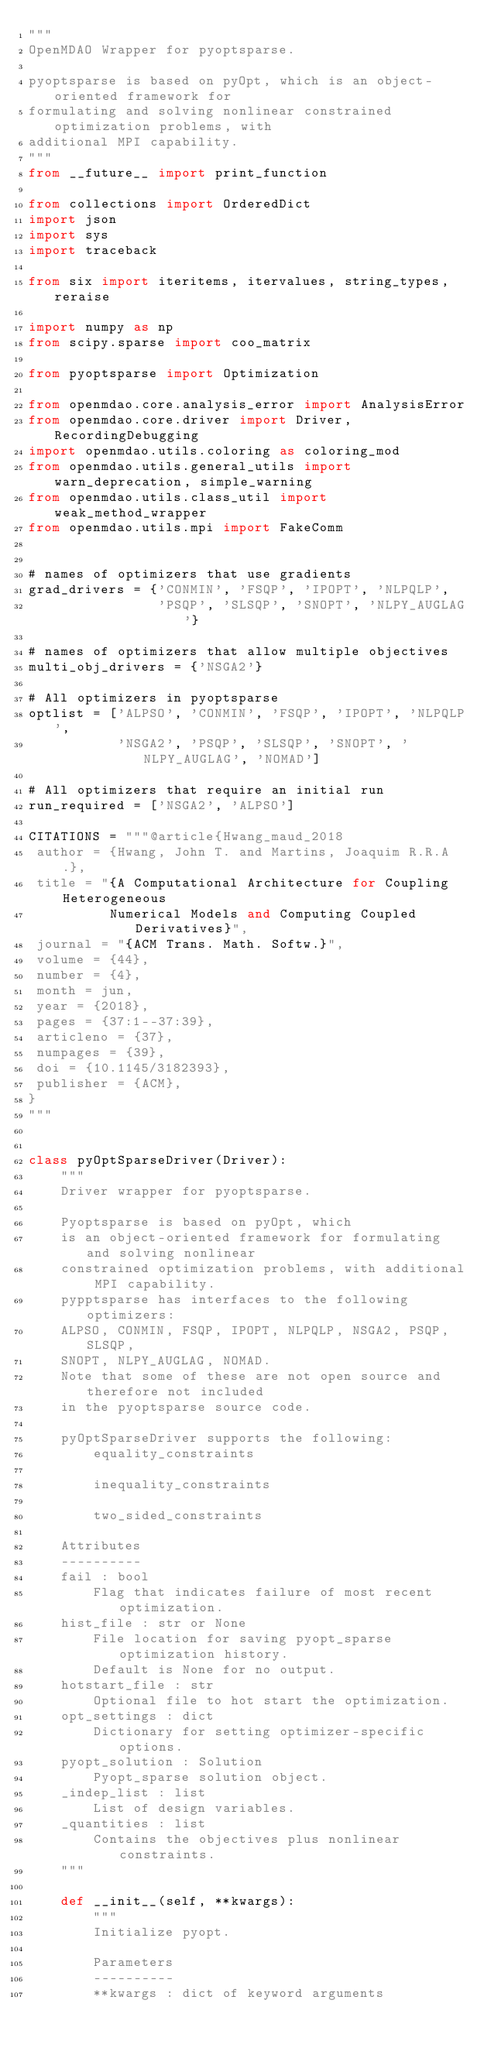Convert code to text. <code><loc_0><loc_0><loc_500><loc_500><_Python_>"""
OpenMDAO Wrapper for pyoptsparse.

pyoptsparse is based on pyOpt, which is an object-oriented framework for
formulating and solving nonlinear constrained optimization problems, with
additional MPI capability.
"""
from __future__ import print_function

from collections import OrderedDict
import json
import sys
import traceback

from six import iteritems, itervalues, string_types, reraise

import numpy as np
from scipy.sparse import coo_matrix

from pyoptsparse import Optimization

from openmdao.core.analysis_error import AnalysisError
from openmdao.core.driver import Driver, RecordingDebugging
import openmdao.utils.coloring as coloring_mod
from openmdao.utils.general_utils import warn_deprecation, simple_warning
from openmdao.utils.class_util import weak_method_wrapper
from openmdao.utils.mpi import FakeComm


# names of optimizers that use gradients
grad_drivers = {'CONMIN', 'FSQP', 'IPOPT', 'NLPQLP',
                'PSQP', 'SLSQP', 'SNOPT', 'NLPY_AUGLAG'}

# names of optimizers that allow multiple objectives
multi_obj_drivers = {'NSGA2'}

# All optimizers in pyoptsparse
optlist = ['ALPSO', 'CONMIN', 'FSQP', 'IPOPT', 'NLPQLP',
           'NSGA2', 'PSQP', 'SLSQP', 'SNOPT', 'NLPY_AUGLAG', 'NOMAD']

# All optimizers that require an initial run
run_required = ['NSGA2', 'ALPSO']

CITATIONS = """@article{Hwang_maud_2018
 author = {Hwang, John T. and Martins, Joaquim R.R.A.},
 title = "{A Computational Architecture for Coupling Heterogeneous
          Numerical Models and Computing Coupled Derivatives}",
 journal = "{ACM Trans. Math. Softw.}",
 volume = {44},
 number = {4},
 month = jun,
 year = {2018},
 pages = {37:1--37:39},
 articleno = {37},
 numpages = {39},
 doi = {10.1145/3182393},
 publisher = {ACM},
}
"""


class pyOptSparseDriver(Driver):
    """
    Driver wrapper for pyoptsparse.

    Pyoptsparse is based on pyOpt, which
    is an object-oriented framework for formulating and solving nonlinear
    constrained optimization problems, with additional MPI capability.
    pypptsparse has interfaces to the following optimizers:
    ALPSO, CONMIN, FSQP, IPOPT, NLPQLP, NSGA2, PSQP, SLSQP,
    SNOPT, NLPY_AUGLAG, NOMAD.
    Note that some of these are not open source and therefore not included
    in the pyoptsparse source code.

    pyOptSparseDriver supports the following:
        equality_constraints

        inequality_constraints

        two_sided_constraints

    Attributes
    ----------
    fail : bool
        Flag that indicates failure of most recent optimization.
    hist_file : str or None
        File location for saving pyopt_sparse optimization history.
        Default is None for no output.
    hotstart_file : str
        Optional file to hot start the optimization.
    opt_settings : dict
        Dictionary for setting optimizer-specific options.
    pyopt_solution : Solution
        Pyopt_sparse solution object.
    _indep_list : list
        List of design variables.
    _quantities : list
        Contains the objectives plus nonlinear constraints.
    """

    def __init__(self, **kwargs):
        """
        Initialize pyopt.

        Parameters
        ----------
        **kwargs : dict of keyword arguments</code> 